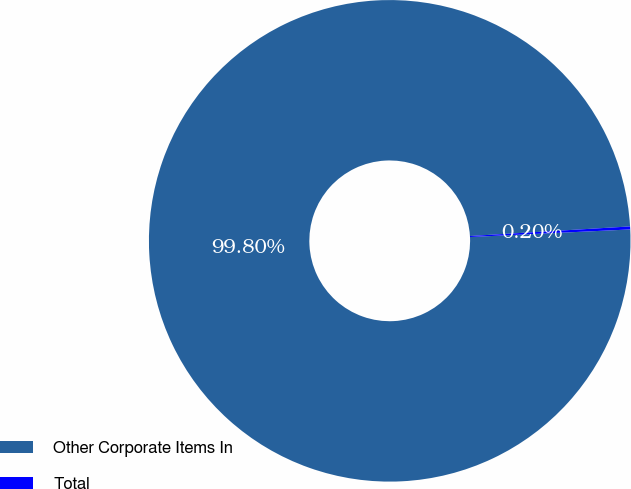Convert chart to OTSL. <chart><loc_0><loc_0><loc_500><loc_500><pie_chart><fcel>Other Corporate Items In<fcel>Total<nl><fcel>99.8%<fcel>0.2%<nl></chart> 